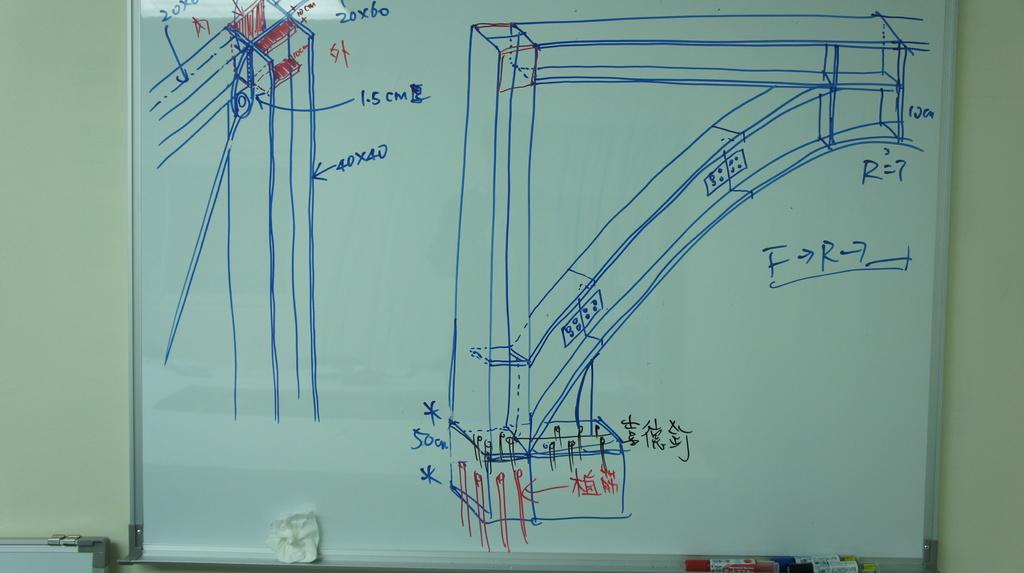<image>
Write a terse but informative summary of the picture. the number 5 is written on the white board 